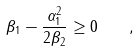<formula> <loc_0><loc_0><loc_500><loc_500>\beta _ { 1 } - \frac { \alpha _ { 1 } ^ { 2 } } { 2 \beta _ { 2 } } \geq 0 \quad ,</formula> 